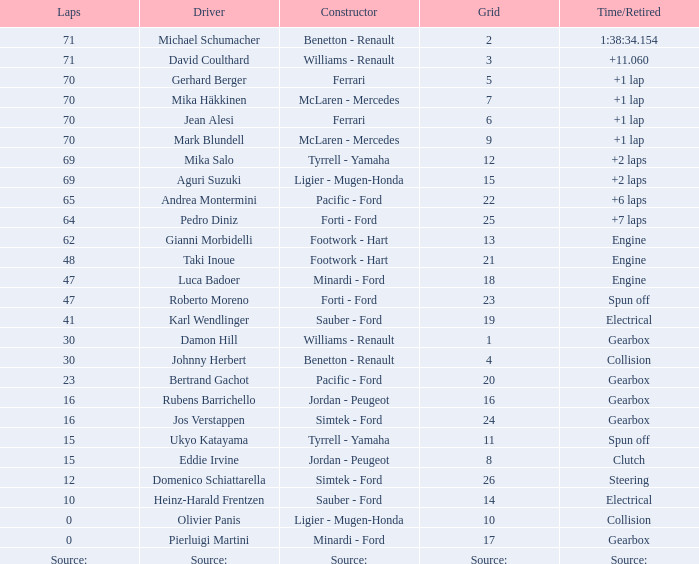David Coulthard was the driver in which grid? 3.0. 